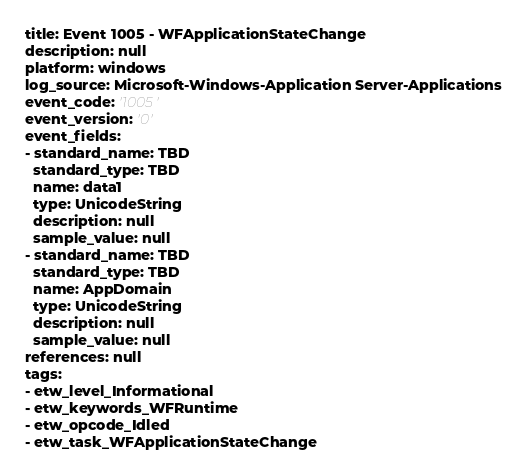<code> <loc_0><loc_0><loc_500><loc_500><_YAML_>title: Event 1005 - WFApplicationStateChange
description: null
platform: windows
log_source: Microsoft-Windows-Application Server-Applications
event_code: '1005'
event_version: '0'
event_fields:
- standard_name: TBD
  standard_type: TBD
  name: data1
  type: UnicodeString
  description: null
  sample_value: null
- standard_name: TBD
  standard_type: TBD
  name: AppDomain
  type: UnicodeString
  description: null
  sample_value: null
references: null
tags:
- etw_level_Informational
- etw_keywords_WFRuntime
- etw_opcode_Idled
- etw_task_WFApplicationStateChange
</code> 